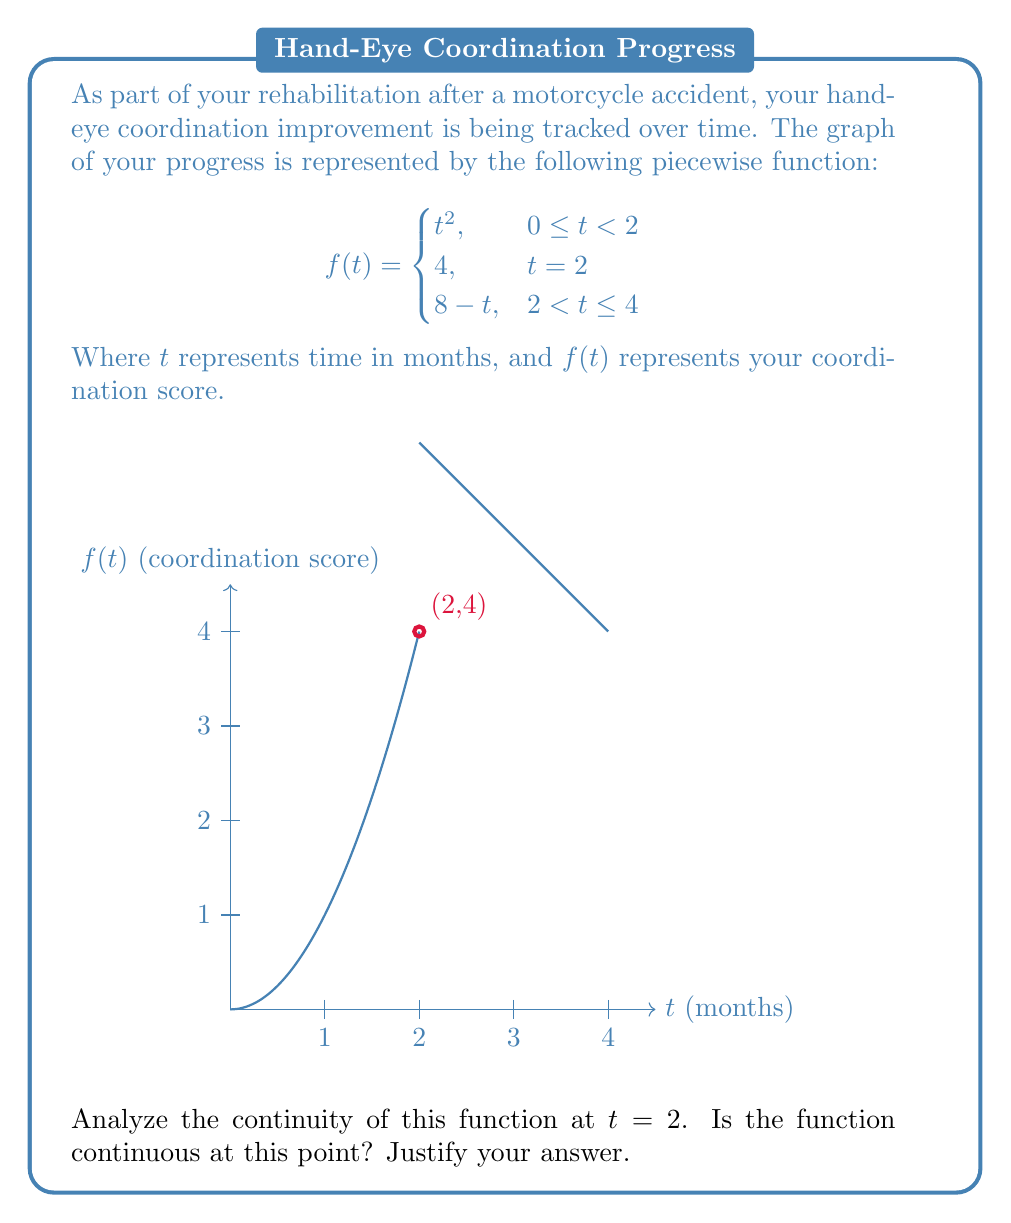Can you answer this question? To determine if the function is continuous at $t = 2$, we need to check three conditions:

1. $f(2)$ must exist
2. $\lim_{t \to 2^-} f(t)$ must exist
3. $\lim_{t \to 2^+} f(t)$ must exist
4. All three values must be equal

Step 1: Check if $f(2)$ exists
From the given function, we can see that $f(2) = 4$. So $f(2)$ exists.

Step 2: Evaluate $\lim_{t \to 2^-} f(t)$
As $t$ approaches 2 from the left, we use the first piece of the function:
$$\lim_{t \to 2^-} f(t) = \lim_{t \to 2^-} t^2 = 2^2 = 4$$

Step 3: Evaluate $\lim_{t \to 2^+} f(t)$
As $t$ approaches 2 from the right, we use the third piece of the function:
$$\lim_{t \to 2^+} f(t) = \lim_{t \to 2^+} (8-t) = 8-2 = 6$$

Step 4: Compare the values
$f(2) = 4$
$\lim_{t \to 2^-} f(t) = 4$
$\lim_{t \to 2^+} f(t) = 6$

We can see that while $f(2)$ is equal to the left-hand limit, it is not equal to the right-hand limit. Therefore, the function is not continuous at $t = 2$.
Answer: Not continuous at $t = 2$ 